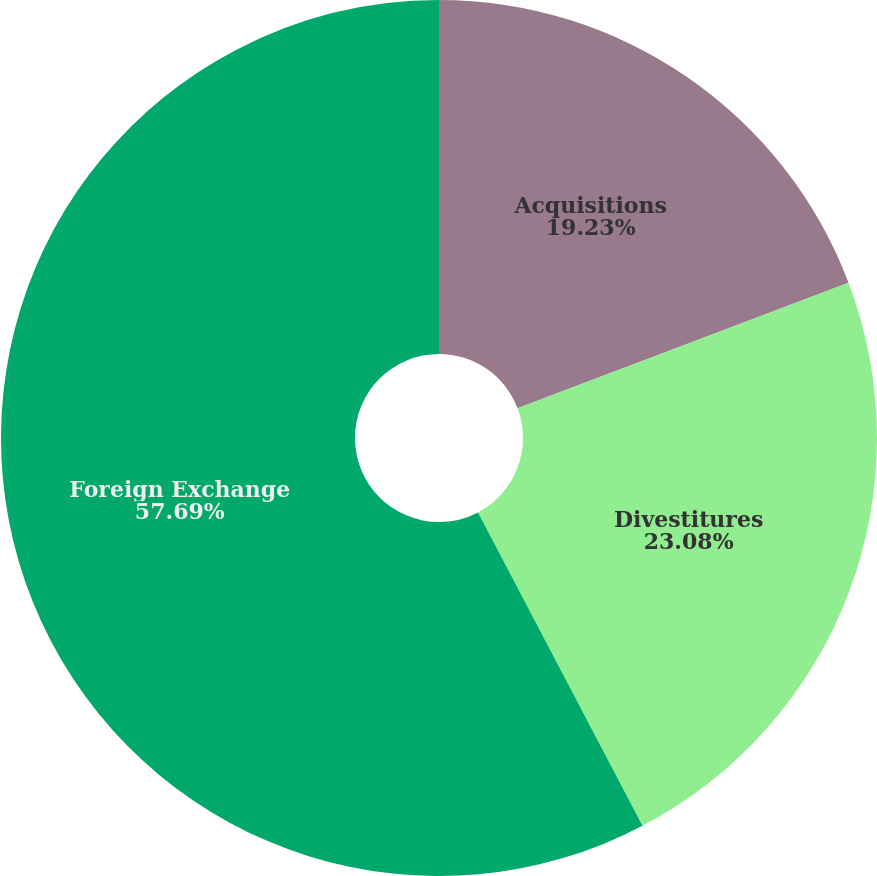Convert chart to OTSL. <chart><loc_0><loc_0><loc_500><loc_500><pie_chart><fcel>Acquisitions<fcel>Divestitures<fcel>Foreign Exchange<nl><fcel>19.23%<fcel>23.08%<fcel>57.69%<nl></chart> 